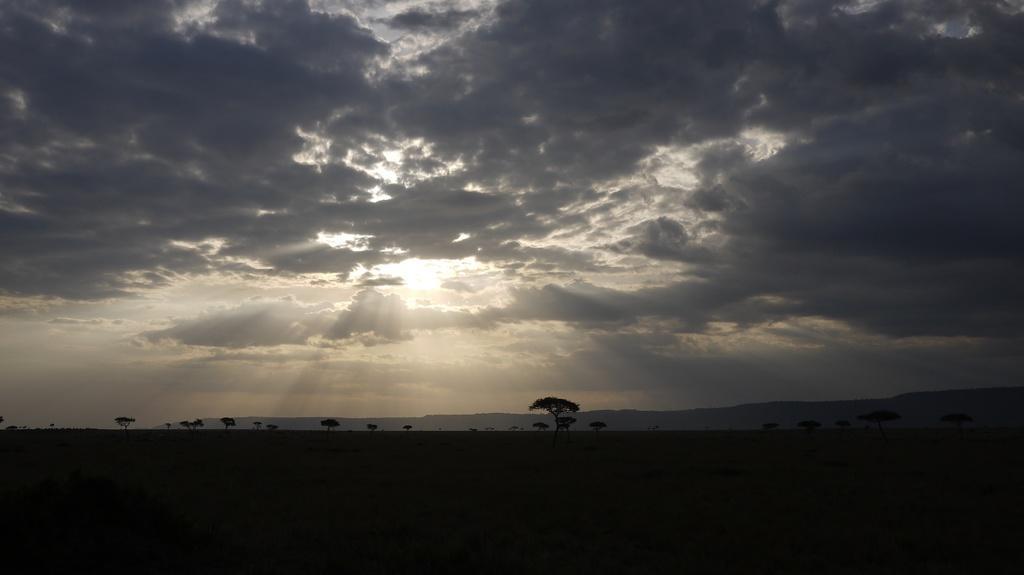How would you summarize this image in a sentence or two? In this image we can see trees, hills, sky and clouds. 